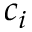Convert formula to latex. <formula><loc_0><loc_0><loc_500><loc_500>c _ { i }</formula> 